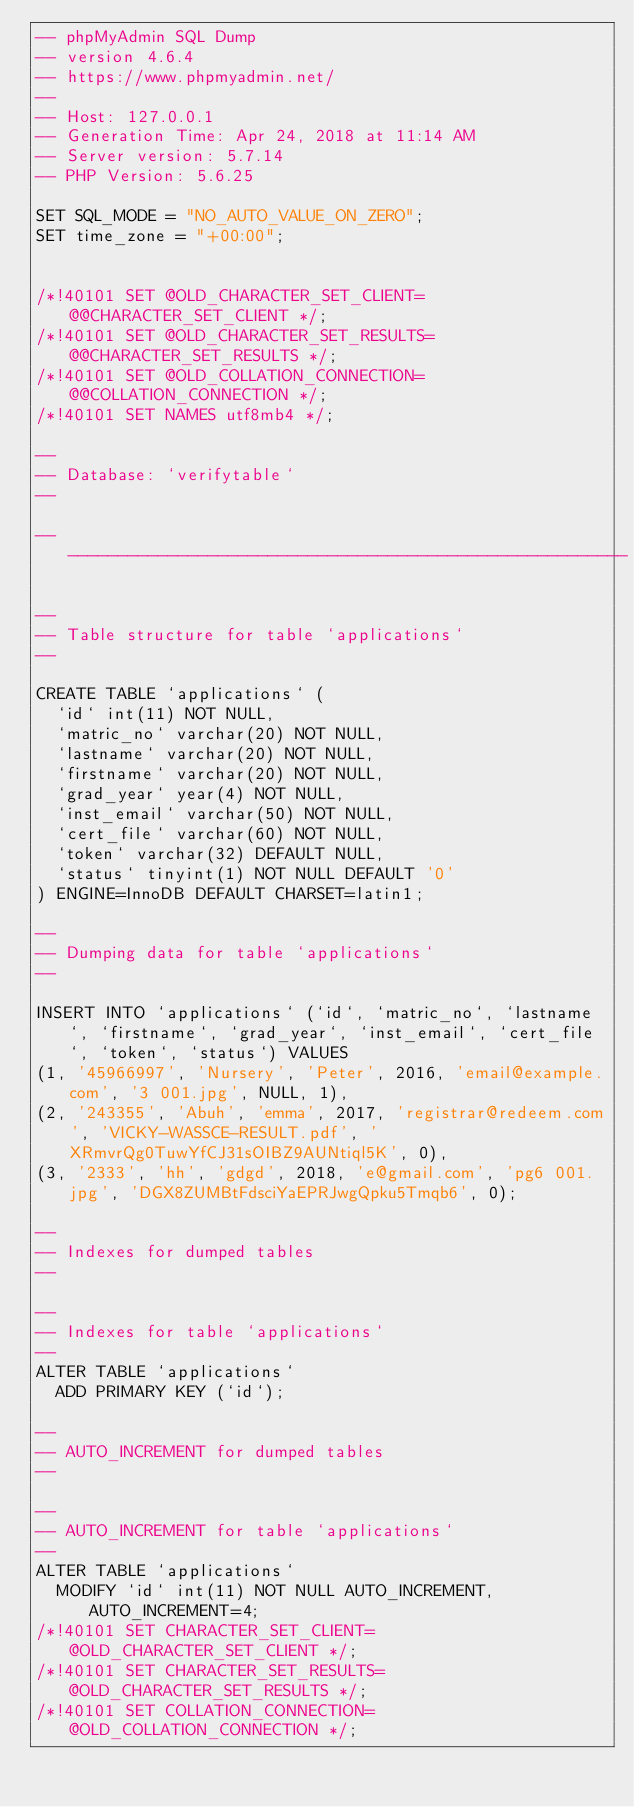<code> <loc_0><loc_0><loc_500><loc_500><_SQL_>-- phpMyAdmin SQL Dump
-- version 4.6.4
-- https://www.phpmyadmin.net/
--
-- Host: 127.0.0.1
-- Generation Time: Apr 24, 2018 at 11:14 AM
-- Server version: 5.7.14
-- PHP Version: 5.6.25

SET SQL_MODE = "NO_AUTO_VALUE_ON_ZERO";
SET time_zone = "+00:00";


/*!40101 SET @OLD_CHARACTER_SET_CLIENT=@@CHARACTER_SET_CLIENT */;
/*!40101 SET @OLD_CHARACTER_SET_RESULTS=@@CHARACTER_SET_RESULTS */;
/*!40101 SET @OLD_COLLATION_CONNECTION=@@COLLATION_CONNECTION */;
/*!40101 SET NAMES utf8mb4 */;

--
-- Database: `verifytable`
--

-- --------------------------------------------------------

--
-- Table structure for table `applications`
--

CREATE TABLE `applications` (
  `id` int(11) NOT NULL,
  `matric_no` varchar(20) NOT NULL,
  `lastname` varchar(20) NOT NULL,
  `firstname` varchar(20) NOT NULL,
  `grad_year` year(4) NOT NULL,
  `inst_email` varchar(50) NOT NULL,
  `cert_file` varchar(60) NOT NULL,
  `token` varchar(32) DEFAULT NULL,
  `status` tinyint(1) NOT NULL DEFAULT '0'
) ENGINE=InnoDB DEFAULT CHARSET=latin1;

--
-- Dumping data for table `applications`
--

INSERT INTO `applications` (`id`, `matric_no`, `lastname`, `firstname`, `grad_year`, `inst_email`, `cert_file`, `token`, `status`) VALUES
(1, '45966997', 'Nursery', 'Peter', 2016, 'email@example.com', '3 001.jpg', NULL, 1),
(2, '243355', 'Abuh', 'emma', 2017, 'registrar@redeem.com', 'VICKY-WASSCE-RESULT.pdf', 'XRmvrQg0TuwYfCJ31sOIBZ9AUNtiql5K', 0),
(3, '2333', 'hh', 'gdgd', 2018, 'e@gmail.com', 'pg6 001.jpg', 'DGX8ZUMBtFdsciYaEPRJwgQpku5Tmqb6', 0);

--
-- Indexes for dumped tables
--

--
-- Indexes for table `applications`
--
ALTER TABLE `applications`
  ADD PRIMARY KEY (`id`);

--
-- AUTO_INCREMENT for dumped tables
--

--
-- AUTO_INCREMENT for table `applications`
--
ALTER TABLE `applications`
  MODIFY `id` int(11) NOT NULL AUTO_INCREMENT, AUTO_INCREMENT=4;
/*!40101 SET CHARACTER_SET_CLIENT=@OLD_CHARACTER_SET_CLIENT */;
/*!40101 SET CHARACTER_SET_RESULTS=@OLD_CHARACTER_SET_RESULTS */;
/*!40101 SET COLLATION_CONNECTION=@OLD_COLLATION_CONNECTION */;
</code> 